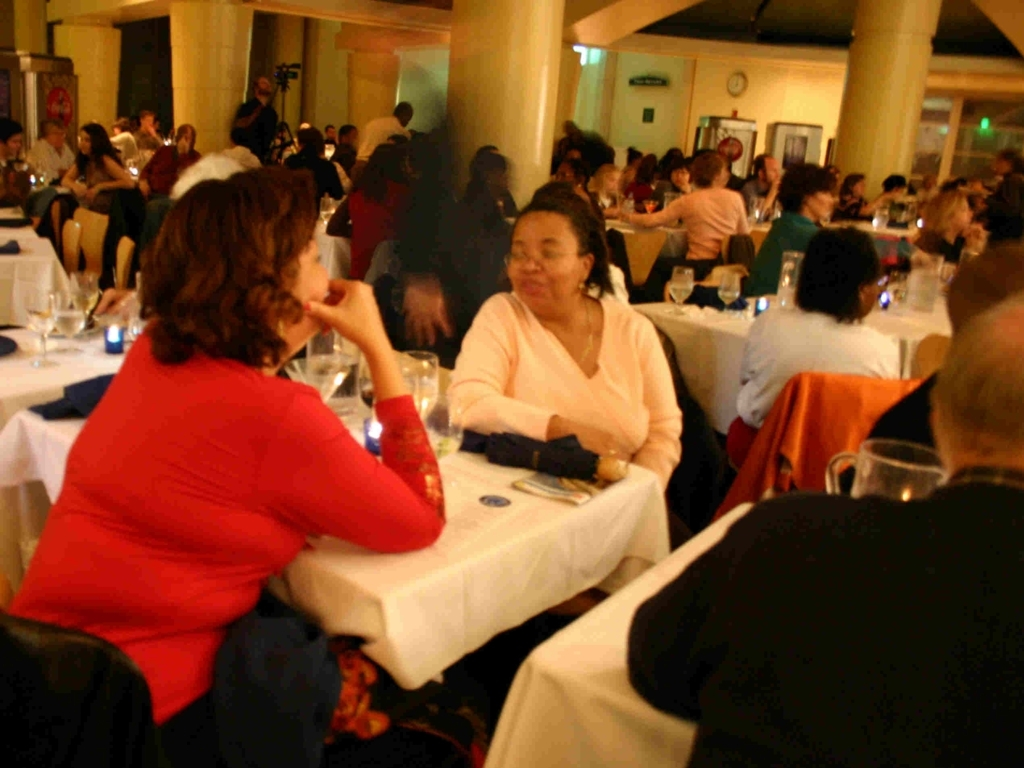Can you describe the atmosphere or mood of this setting? The setting appears to be a social event, possibly a dinner or a gathering, with a warm and bustling atmosphere. People seem to be engaged in conversations and enjoying each other’s company, implying a relaxed and friendly mood. 